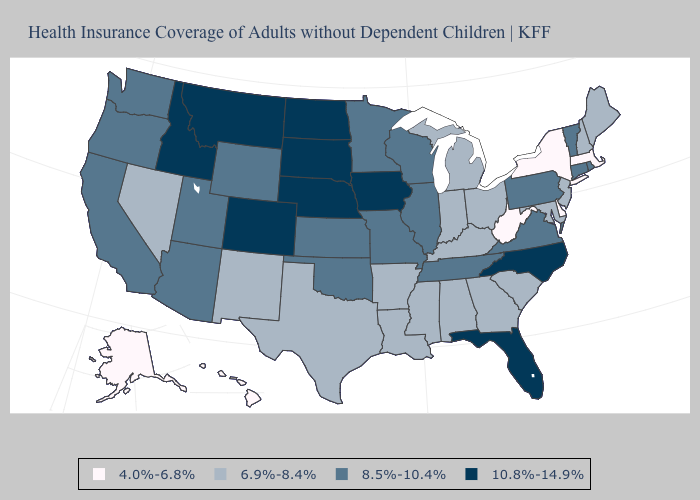Name the states that have a value in the range 4.0%-6.8%?
Be succinct. Alaska, Delaware, Hawaii, Massachusetts, New York, West Virginia. What is the lowest value in states that border Ohio?
Give a very brief answer. 4.0%-6.8%. Name the states that have a value in the range 4.0%-6.8%?
Answer briefly. Alaska, Delaware, Hawaii, Massachusetts, New York, West Virginia. Does Pennsylvania have the lowest value in the USA?
Be succinct. No. Name the states that have a value in the range 10.8%-14.9%?
Quick response, please. Colorado, Florida, Idaho, Iowa, Montana, Nebraska, North Carolina, North Dakota, South Dakota. Which states hav the highest value in the South?
Give a very brief answer. Florida, North Carolina. What is the value of North Carolina?
Keep it brief. 10.8%-14.9%. Does New Hampshire have the lowest value in the Northeast?
Give a very brief answer. No. What is the value of Washington?
Give a very brief answer. 8.5%-10.4%. What is the value of Montana?
Short answer required. 10.8%-14.9%. Name the states that have a value in the range 4.0%-6.8%?
Give a very brief answer. Alaska, Delaware, Hawaii, Massachusetts, New York, West Virginia. Name the states that have a value in the range 6.9%-8.4%?
Keep it brief. Alabama, Arkansas, Georgia, Indiana, Kentucky, Louisiana, Maine, Maryland, Michigan, Mississippi, Nevada, New Hampshire, New Jersey, New Mexico, Ohio, South Carolina, Texas. Which states hav the highest value in the MidWest?
Concise answer only. Iowa, Nebraska, North Dakota, South Dakota. Does the map have missing data?
Short answer required. No. Does the map have missing data?
Keep it brief. No. 